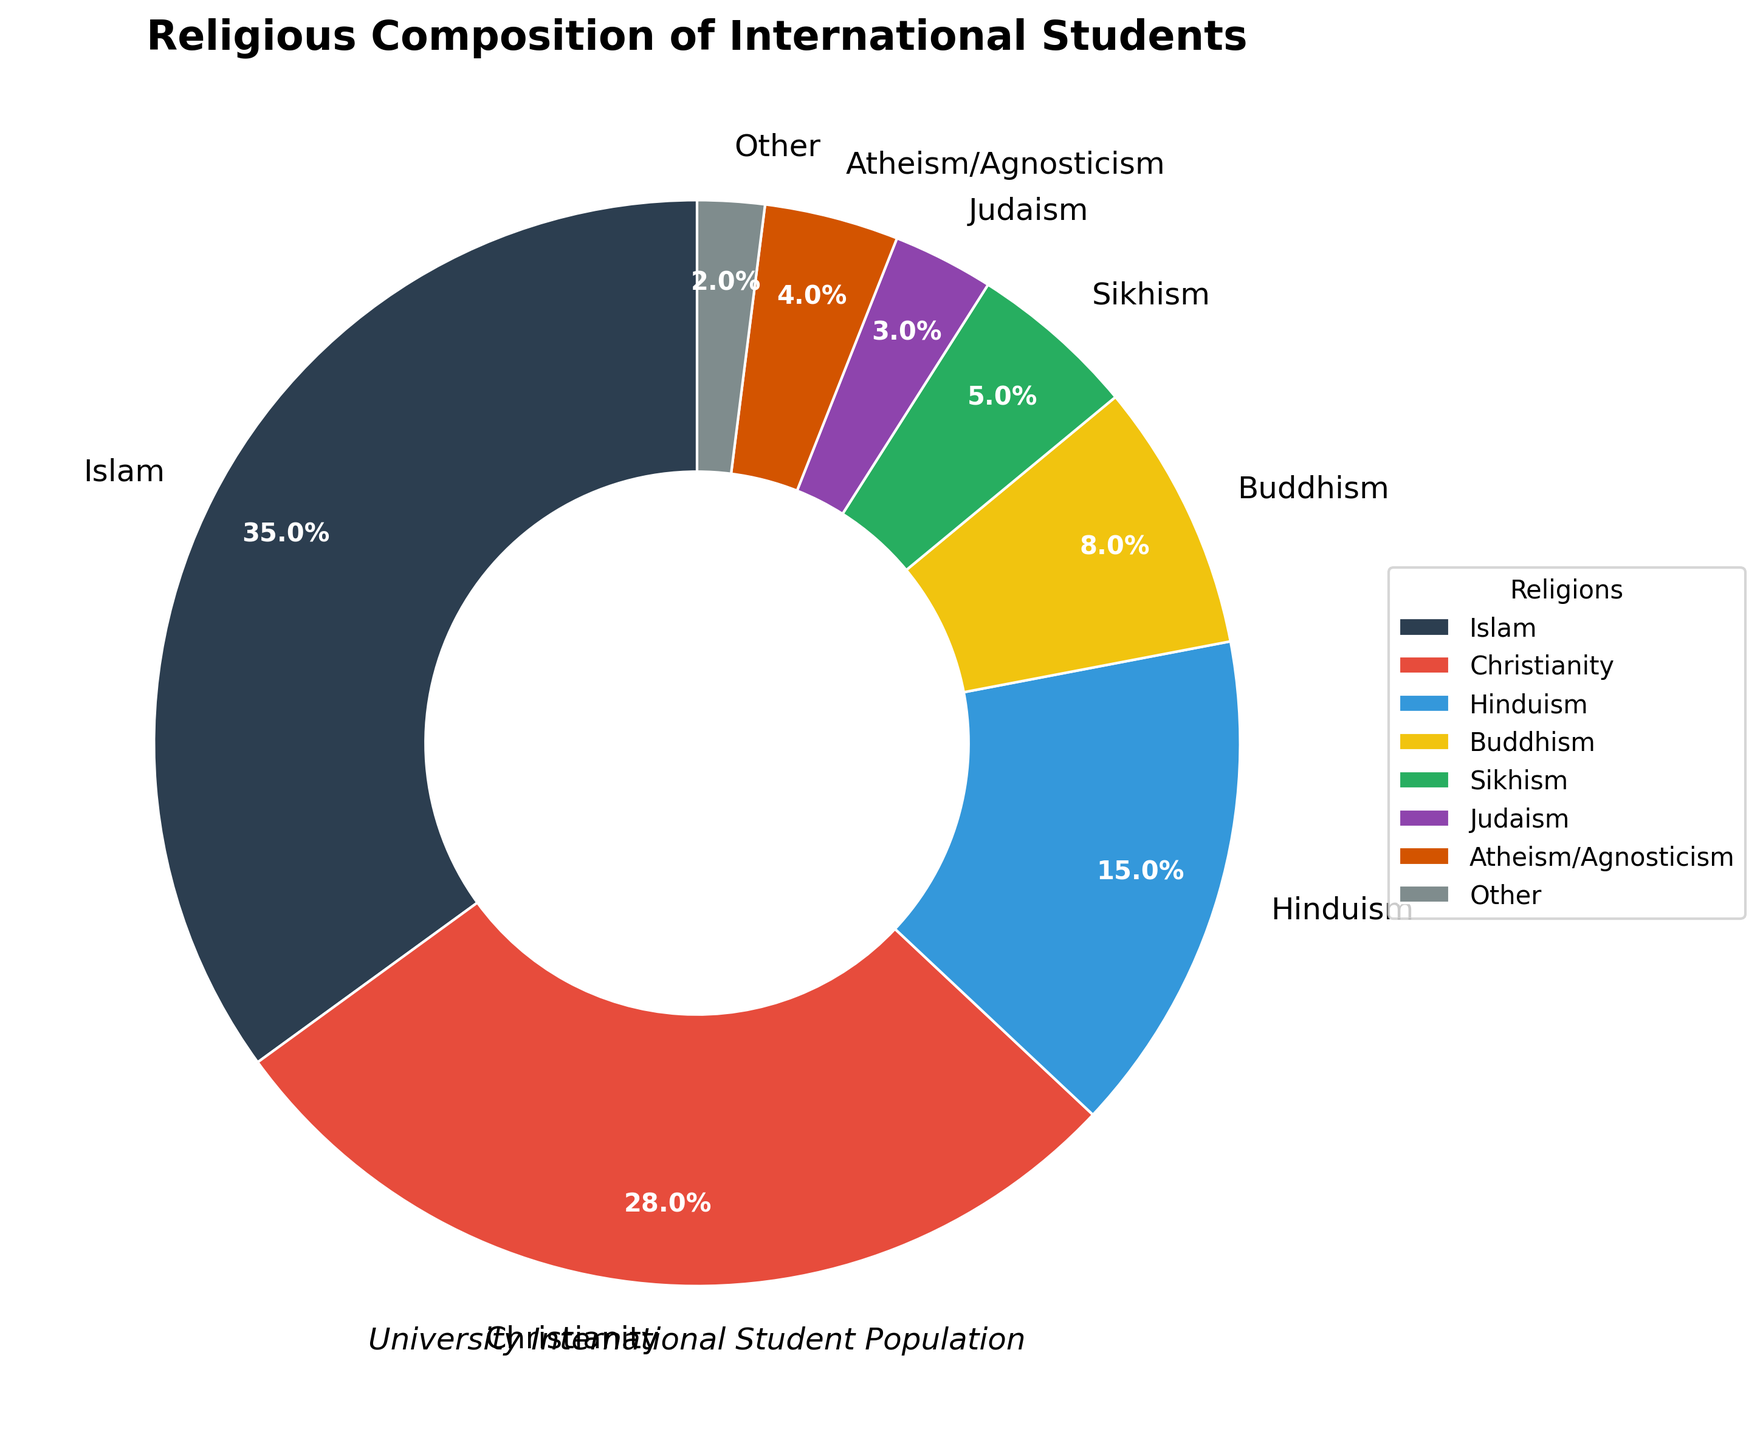What is the combined percentage of students identifying with Hinduism and Buddhism? To find the combined percentage, add the percentage of students who identify with Hinduism (15%) to the percentage of students who identify with Buddhism (8%). Therefore, 15% + 8% = 23%.
Answer: 23% Which religion has a higher percentage of students, Christianity or Islam? To compare the two, we see that Christianity has 28% while Islam has 35%. Since 35% is greater than 28%, Islam has a higher percentage of students than Christianity.
Answer: Islam How many religions have a percentage of 5% or less? The religions with 5% or less are Sikhism (5%), Judaism (3%), Atheism/Agnosticism (4%), and Other (2%). Counting these, there are 4 religions.
Answer: 4 What color is used to represent the percentage of students identifying with Judaism? By observing the pie chart, the wedge representing students who identify with Judaism is in a dark purple color.
Answer: Dark purple If you combine the percentages of Sikhism, Judaism, Atheism/Agnosticism, and Other, what do you get? To find the combined percentage, add Sikhism (5%) + Judaism (3%) + Atheism/Agnosticism (4%) + Other (2%). Therefore, 5% + 3% + 4% + 2% = 14%.
Answer: 14% Which religion has the smallest representation, and what is the percentage? By observing the pie chart, the wedge with the smallest representation is labeled "Other," which has a 2% representation.
Answer: Other, 2% 